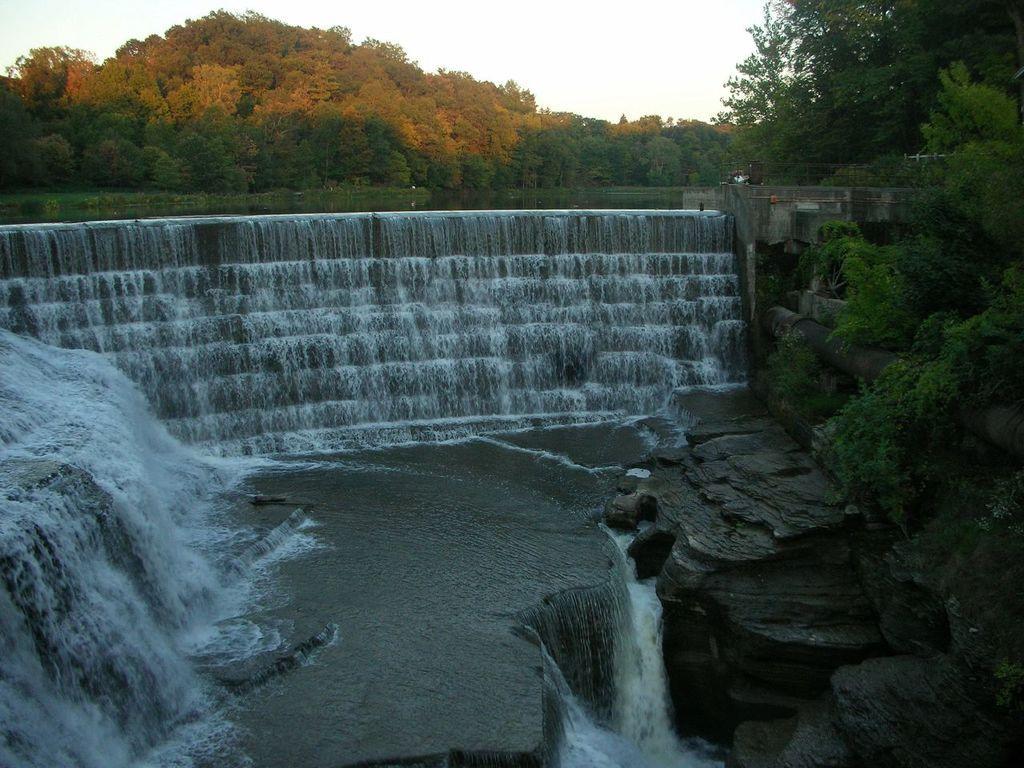Describe this image in one or two sentences. In this image there are rocks, plants , trees, waterfall, and in the background there is sky. 